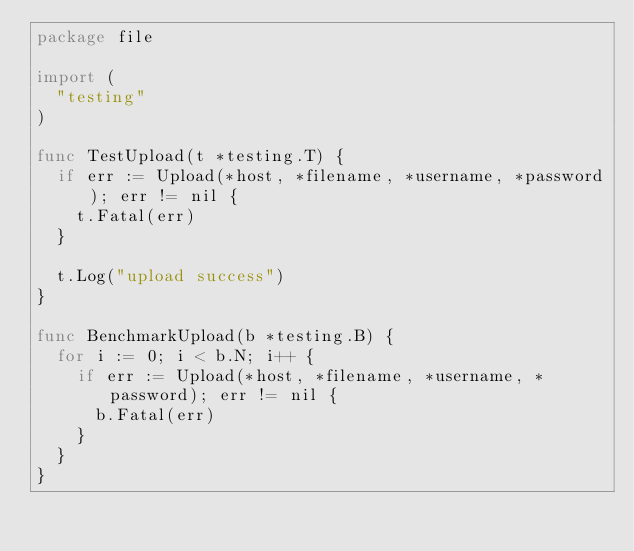Convert code to text. <code><loc_0><loc_0><loc_500><loc_500><_Go_>package file

import (
	"testing"
)

func TestUpload(t *testing.T) {
	if err := Upload(*host, *filename, *username, *password); err != nil {
		t.Fatal(err)
	}

	t.Log("upload success")
}

func BenchmarkUpload(b *testing.B) {
	for i := 0; i < b.N; i++ {
		if err := Upload(*host, *filename, *username, *password); err != nil {
			b.Fatal(err)
		}
	}
}
</code> 